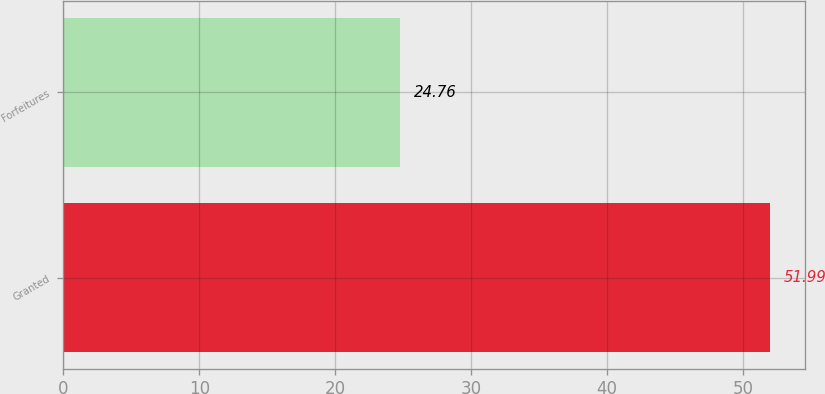<chart> <loc_0><loc_0><loc_500><loc_500><bar_chart><fcel>Granted<fcel>Forfeitures<nl><fcel>51.99<fcel>24.76<nl></chart> 